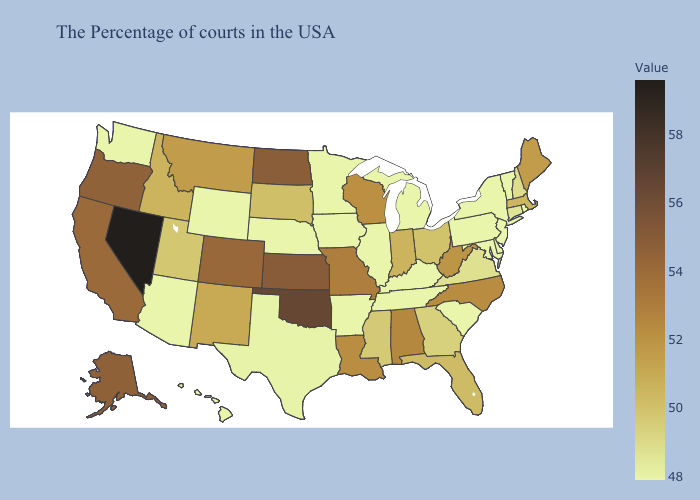Among the states that border Colorado , does Utah have the lowest value?
Answer briefly. No. Does Maine have the highest value in the Northeast?
Concise answer only. Yes. Among the states that border Nebraska , does Kansas have the highest value?
Keep it brief. Yes. Which states have the highest value in the USA?
Short answer required. Nevada. 